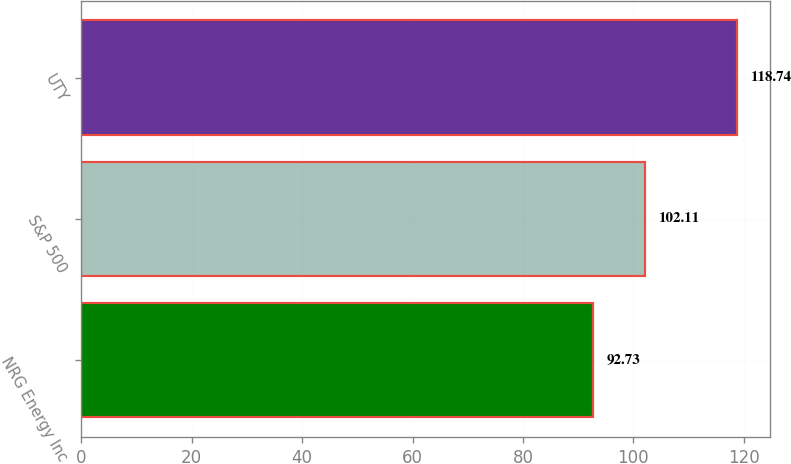<chart> <loc_0><loc_0><loc_500><loc_500><bar_chart><fcel>NRG Energy Inc<fcel>S&P 500<fcel>UTY<nl><fcel>92.73<fcel>102.11<fcel>118.74<nl></chart> 